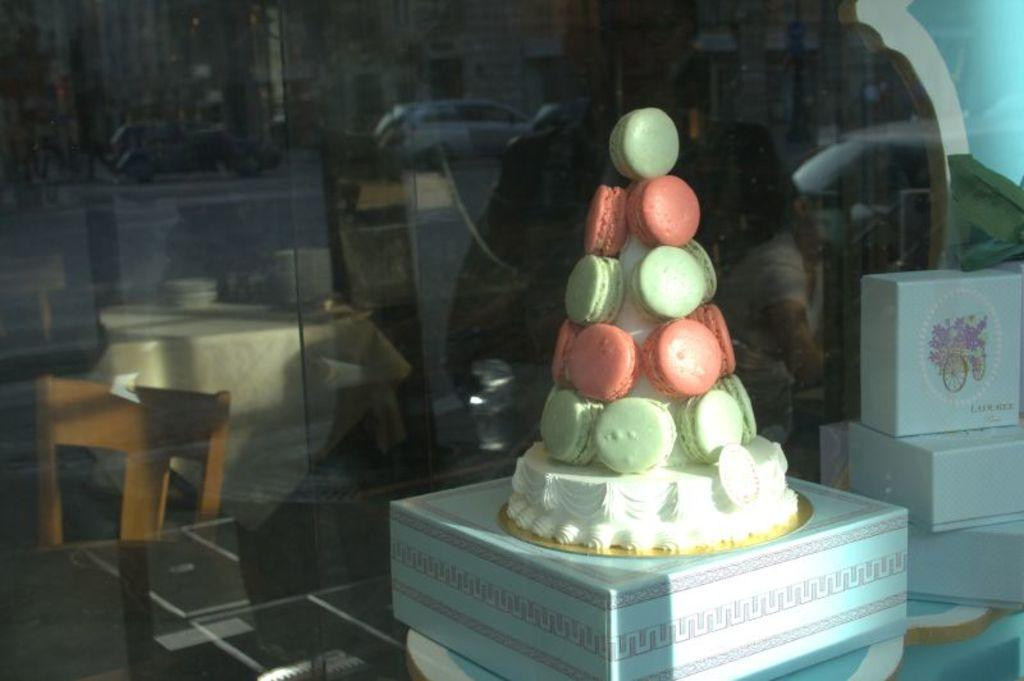What is placed on a box in the image? There is a cake on a box in the image. What else can be seen on the table in the image? There are additional boxes on the table in the image. What is the table positioned in front of in the image? The table is in front of a glass wall in the image. How many arms are visible in the image? There are no arms visible in the image. What type of bite can be seen on the cake in the image? There is no bite visible on the cake in the image. 